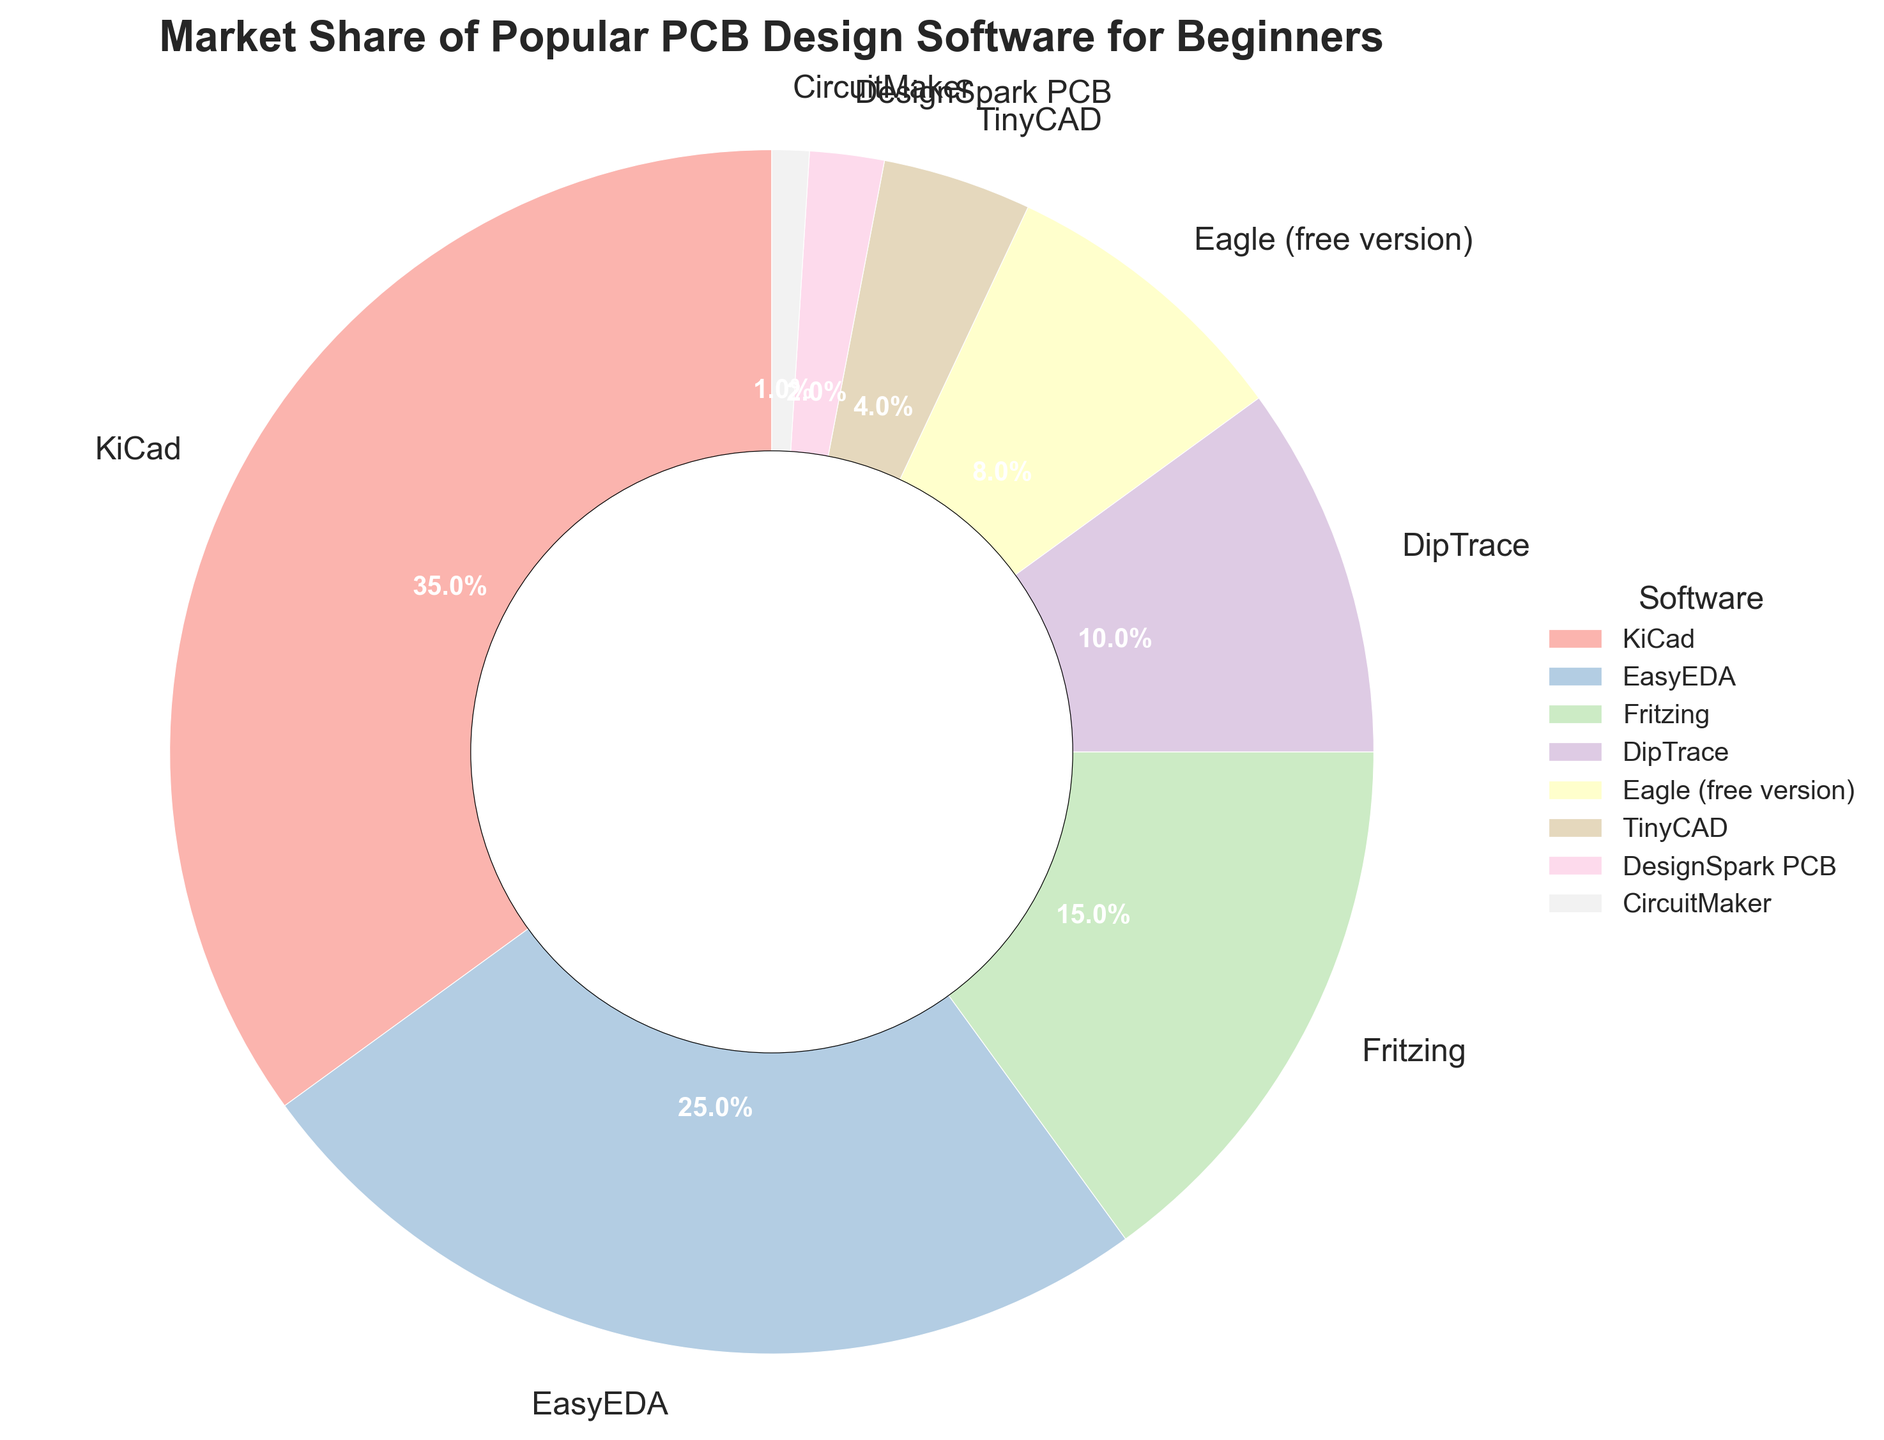Which software has the largest market share? By looking at the figure, it can be easily seen that the section labeled "KiCad" is the largest, indicating it has the largest market share.
Answer: KiCad What is the combined market share of Fritzing and EasyEDA? The market share of Fritzing is 15%, and that of EasyEDA is 25%. Adding these together gives 15% + 25% = 40%.
Answer: 40% Which software has a higher market share, DipTrace or Eagle (free version)? DipTrace has a market share of 10%, whereas Eagle (free version) has a market share of 8%. Since 10% is greater than 8%, DipTrace has a higher market share.
Answer: DipTrace What is the difference in market share between KiCad and EasyEDA? KiCad has a market share of 35%, and EasyEDA has 25%. The difference is calculated as 35% - 25% = 10%.
Answer: 10% What percentage of the market share is occupied by software with less than a 5% share? The software with less than 5% market share are TinyCAD (4%), DesignSpark PCB (2%), and CircuitMaker (1%). Adding these gives 4% + 2% + 1% = 7%.
Answer: 7% Considering the visual size of the pie sections, which software appears to have the smallest market share? The smallest section of the pie chart is labeled "CircuitMaker," indicating it has the smallest market share.
Answer: CircuitMaker What is the average market share of KiCad, EasyEDA, and Fritzing? The market shares are KiCad 35%, EasyEDA 25%, and Fritzing 15%. The sum of these market shares is 35% + 25% + 15% = 75%, and the average is 75% / 3 = 25%.
Answer: 25% How does the market share of TinyCAD compare visually to that of DesignSpark PCB? By visually examining the pie chart, we can see that the section for TinyCAD (4%) is larger than that for DesignSpark PCB (2%), indicating TinyCAD has a higher market share.
Answer: TinyCAD has a higher market share than DesignSpark PCB 